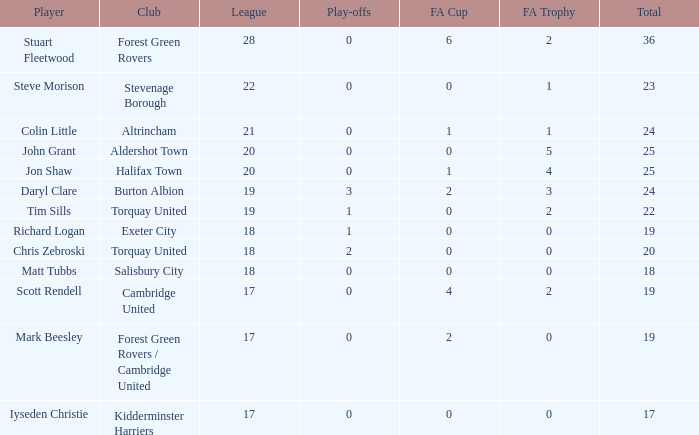What is the average number of play-offs when the league size was larger than 18, where john grant was the athlete and the aggregate number was more than 25? None. 